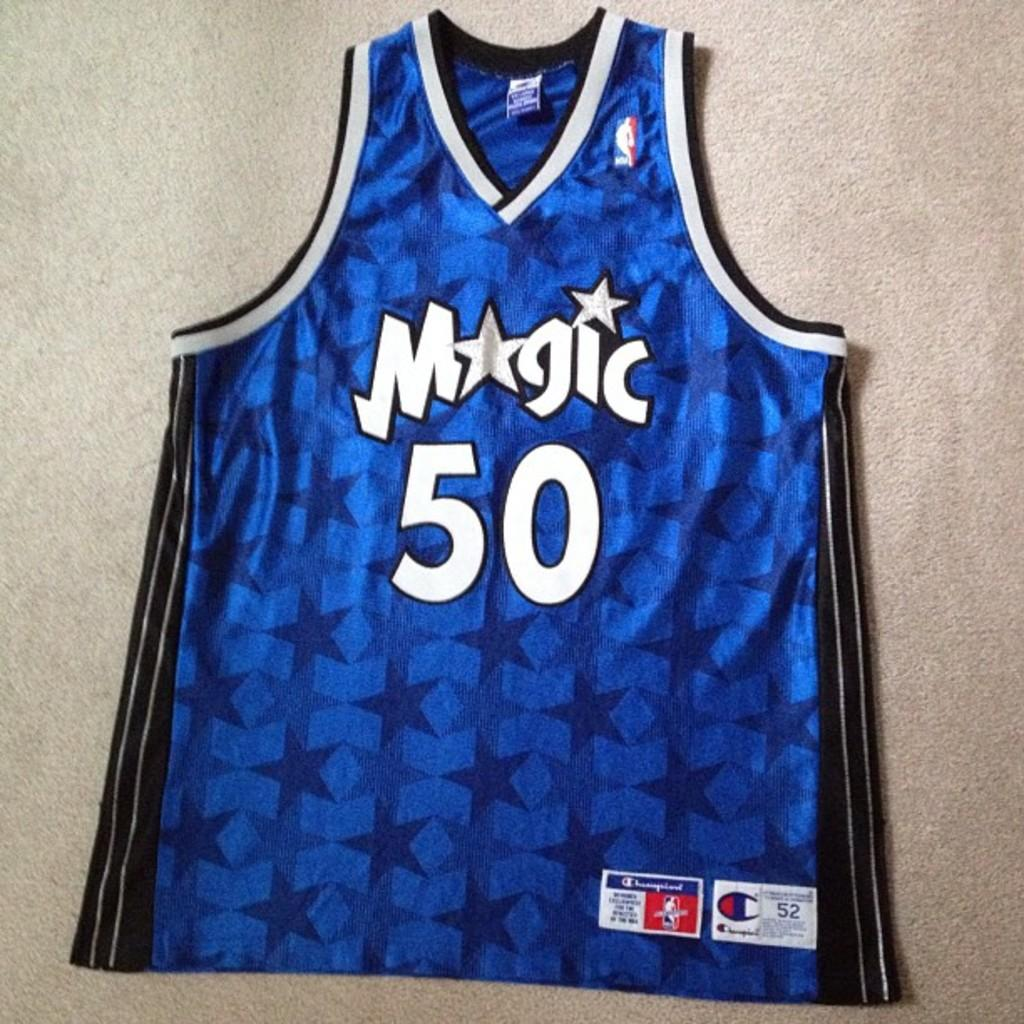<image>
Render a clear and concise summary of the photo. A blue Magic jersey with the number 50 sits against a grey background 